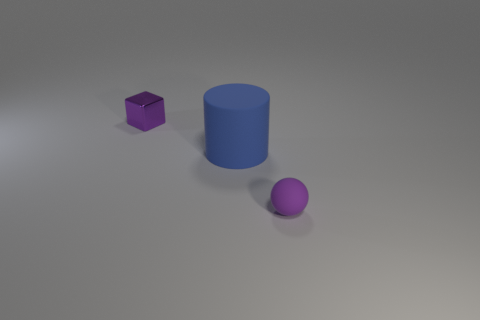There is a object that is on the right side of the small metallic object and behind the tiny matte ball; what material is it? rubber 